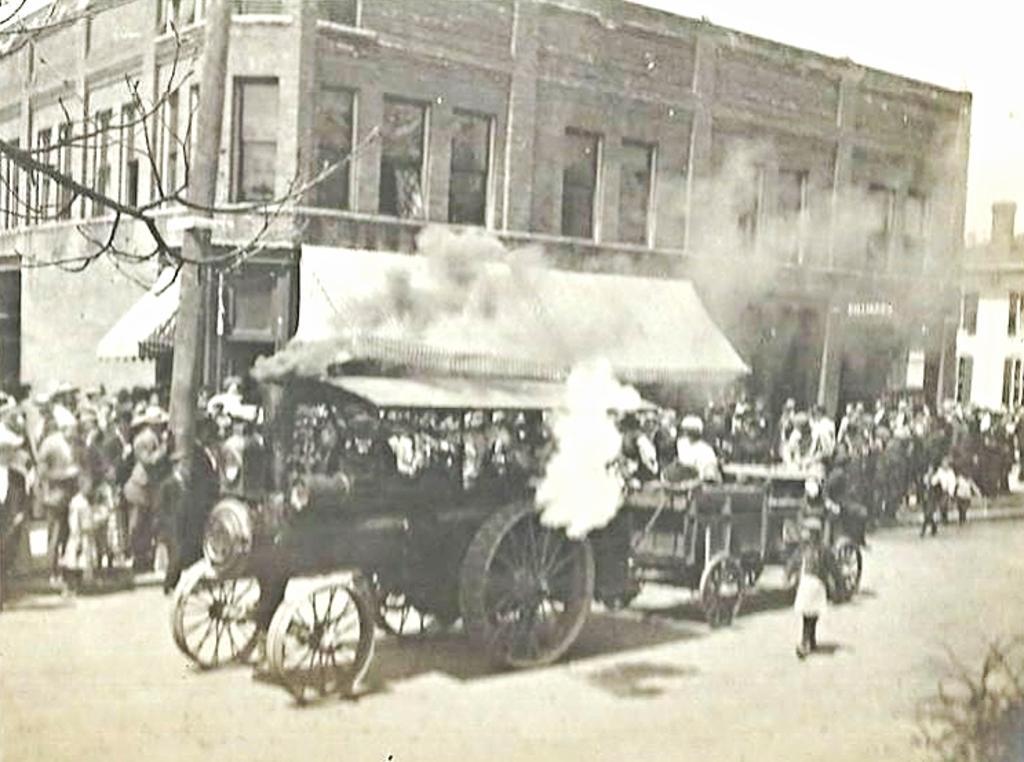In one or two sentences, can you explain what this image depicts? In this image we can see buildings, windows, a tree, there are a few people standing on the pavement, there are vehicles on the road, also we can see a pole. 